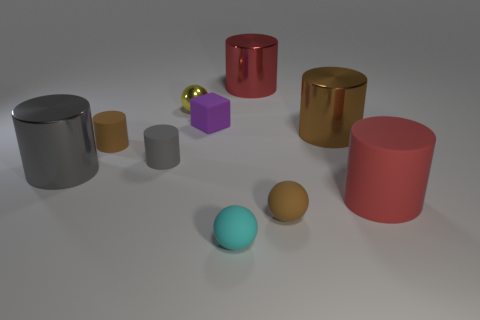Subtract all large gray cylinders. How many cylinders are left? 5 Subtract all yellow spheres. How many gray cylinders are left? 2 Subtract all gray cylinders. How many cylinders are left? 4 Subtract all green spheres. Subtract all purple cubes. How many spheres are left? 3 Subtract all balls. How many objects are left? 7 Add 9 red matte cylinders. How many red matte cylinders are left? 10 Add 2 small purple rubber cubes. How many small purple rubber cubes exist? 3 Subtract 0 green cylinders. How many objects are left? 10 Subtract all purple cylinders. Subtract all yellow metallic spheres. How many objects are left? 9 